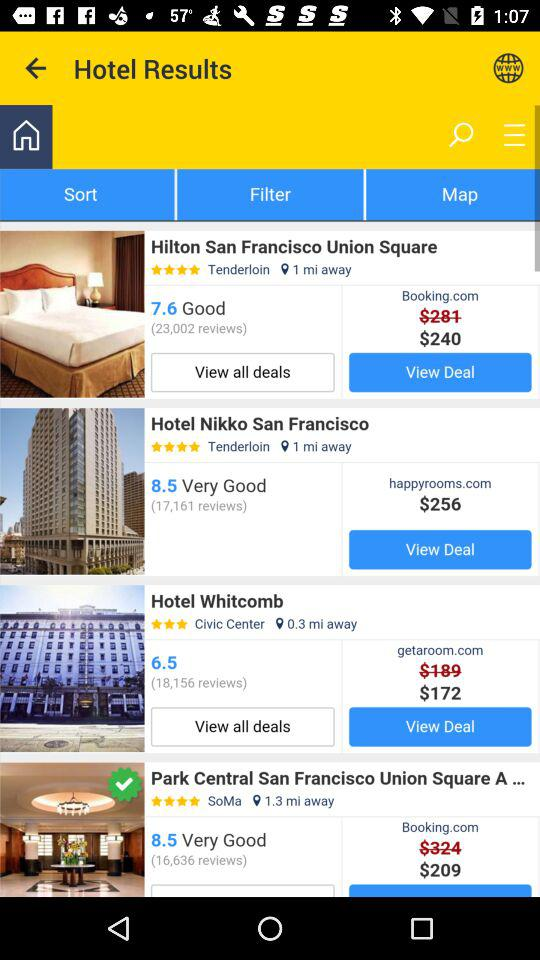How many miles away is Hotel San Francisco Union Square? It is 1 mile away. 